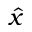Convert formula to latex. <formula><loc_0><loc_0><loc_500><loc_500>\hat { x }</formula> 